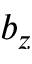Convert formula to latex. <formula><loc_0><loc_0><loc_500><loc_500>b _ { z }</formula> 